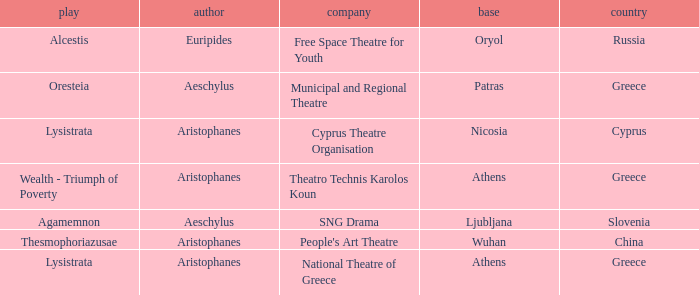What is the base when the play is thesmophoriazusae? Wuhan. 